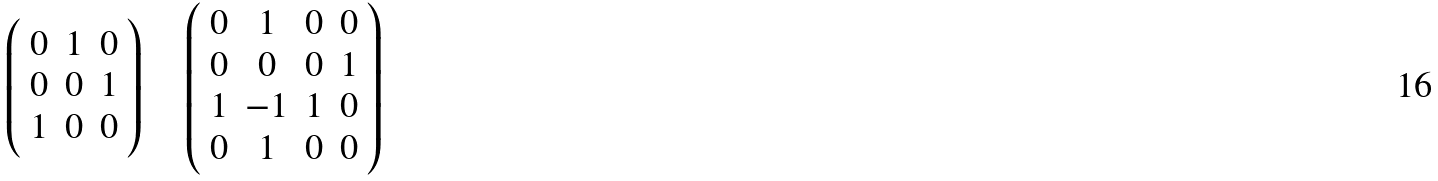Convert formula to latex. <formula><loc_0><loc_0><loc_500><loc_500>\left ( \begin{array} { c c c } 0 & 1 & 0 \\ 0 & 0 & 1 \\ 1 & 0 & 0 \end{array} \right ) \quad \left ( \begin{array} { c c c c } 0 & 1 & 0 & 0 \\ 0 & 0 & 0 & 1 \\ 1 & - 1 & 1 & 0 \\ 0 & 1 & 0 & 0 \end{array} \right )</formula> 